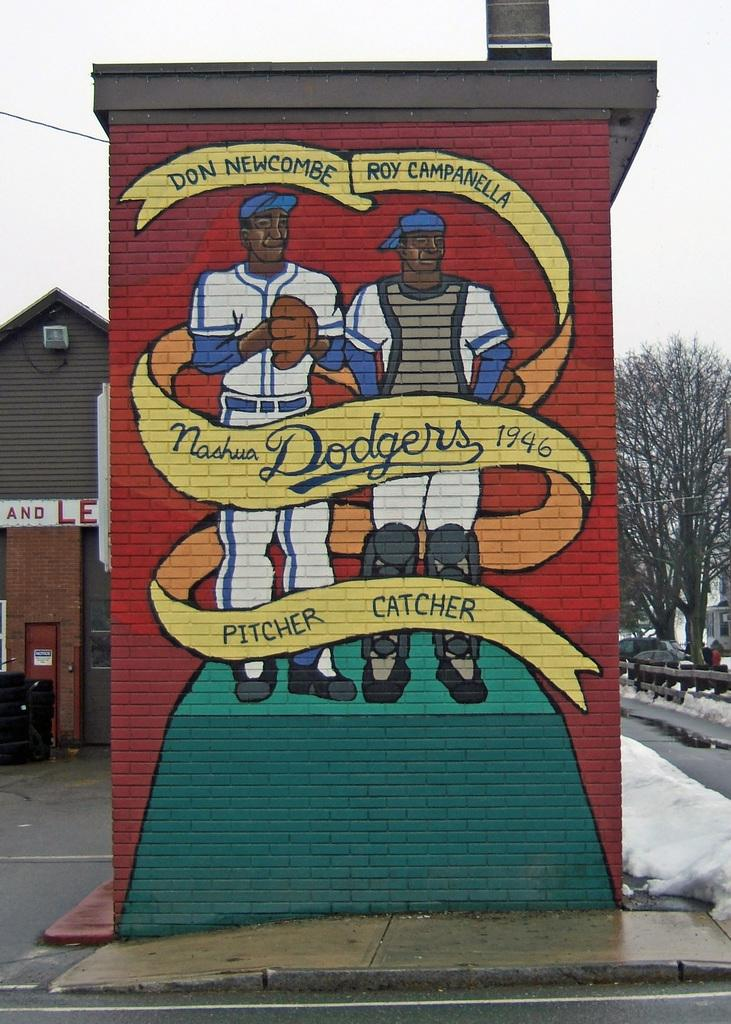What is depicted on the wall in the image? There is a painting of persons on a wall. What else is on the wall besides the painting? There is text on the wall. What is the weather like in the image? There is snow in the image, indicating a cold or wintery environment. What can be seen in the background of the image? There is a house, trees, vehicles, objects, and the sky visible in the background of the image. What type of protest is taking place in the image? There is no protest present in the image; it features a painting of persons on a wall, text, snow, a house, trees, vehicles, objects, and the sky in the background. What does the father of the person in the painting look like? There is no father or person in the painting mentioned in the image, only a painting of persons. 